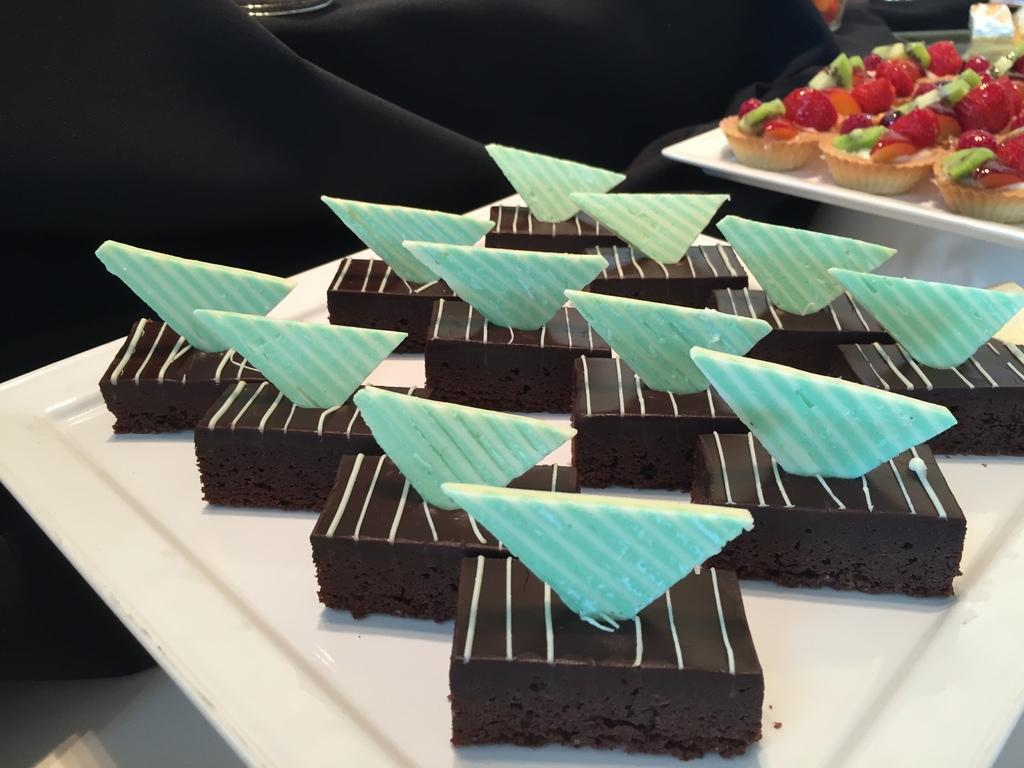What colors are the pastries on the white plate in the image? The pastries on the white plate are black and blue. Can you describe the background of the image? In the background of the image, there are strawberry cupcakes visible. What type of cracker is placed on top of the pastries in the image? There is no cracker present in the image. What order are the pastries arranged in on the plate? The provided facts do not specify the order of the pastries on the plate. 